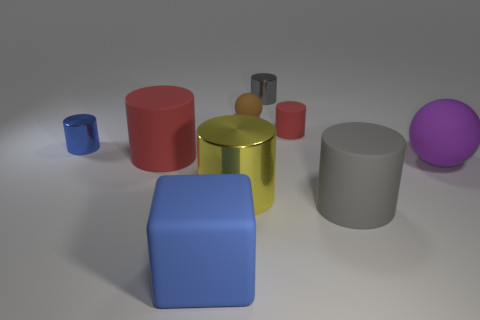Is there a pattern to the arrangement of objects? The objects seem to be arranged without a specific pattern, scattered somewhat randomly across the surface. Can you identify any purposes the objects might have, purely based on their shapes and sizes? Purely based on their shapes and sizes, the objects could be simplistic representations of everyday items, like containers or building blocks for educational purposes. 